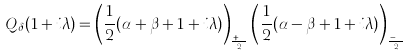Convert formula to latex. <formula><loc_0><loc_0><loc_500><loc_500>Q _ { \delta } ( 1 + i \lambda ) = \left ( \frac { 1 } { 2 } ( \alpha + \beta + 1 + i \lambda ) \right ) _ { \frac { r + s } { 2 } } \left ( \frac { 1 } { 2 } ( \alpha - \beta + 1 + i \lambda ) \right ) _ { \frac { r - s } { 2 } }</formula> 